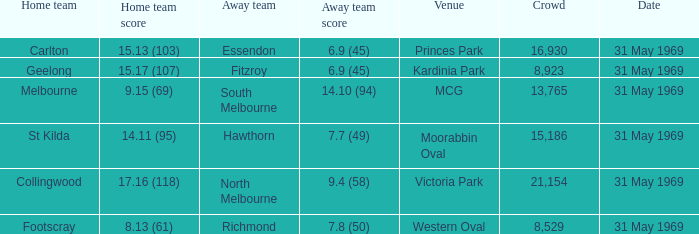Who was the home team in the game where North Melbourne was the away team? 17.16 (118). I'm looking to parse the entire table for insights. Could you assist me with that? {'header': ['Home team', 'Home team score', 'Away team', 'Away team score', 'Venue', 'Crowd', 'Date'], 'rows': [['Carlton', '15.13 (103)', 'Essendon', '6.9 (45)', 'Princes Park', '16,930', '31 May 1969'], ['Geelong', '15.17 (107)', 'Fitzroy', '6.9 (45)', 'Kardinia Park', '8,923', '31 May 1969'], ['Melbourne', '9.15 (69)', 'South Melbourne', '14.10 (94)', 'MCG', '13,765', '31 May 1969'], ['St Kilda', '14.11 (95)', 'Hawthorn', '7.7 (49)', 'Moorabbin Oval', '15,186', '31 May 1969'], ['Collingwood', '17.16 (118)', 'North Melbourne', '9.4 (58)', 'Victoria Park', '21,154', '31 May 1969'], ['Footscray', '8.13 (61)', 'Richmond', '7.8 (50)', 'Western Oval', '8,529', '31 May 1969']]} 